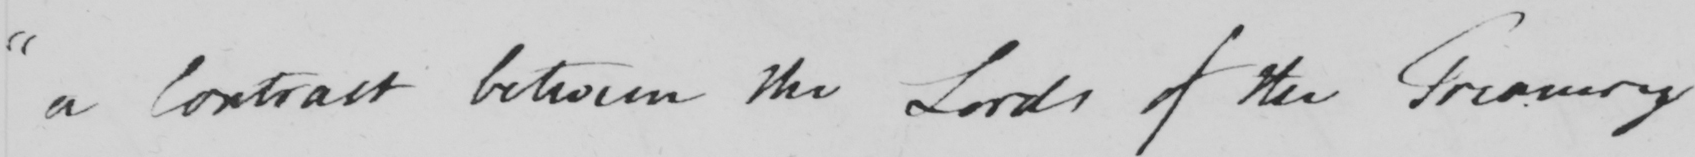What text is written in this handwritten line? " a Contract between the Lords of the Treasury 